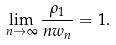Convert formula to latex. <formula><loc_0><loc_0><loc_500><loc_500>\lim _ { n \to \infty } \frac { \rho _ { 1 } } { n w _ { n } } = 1 .</formula> 